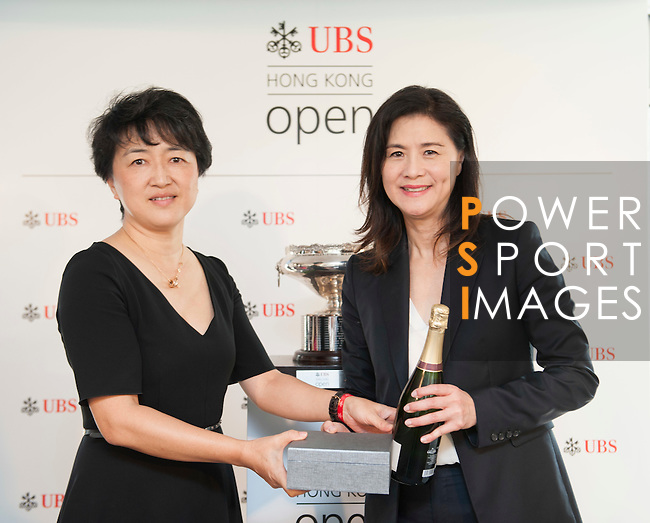Write a detailed description of this image, do not forget about the texts on it if they exist. Also, do not forget to mention the type / style of the image. No bullet points. The color photograph captures two women standing together in front of a promotional display reading 'Hong Kong Open UBS'. The backdrop also includes, in large font, 'POWER SPORT IMAGES'. The woman on the left, sporting black attire with short sleeves, secures the base of a gray presentation box. The woman on the right holds the lid of the box in one hand and a gleaming bottle of champagne in the other, dressed in a dark blazer over a white top. Both women are wearing professional clothing and offer warm smiles towards the camera. In the soft-focus background, a gleaming silver trophy can be glimpsed resting on a pedestal. The image does not overtly suggest a sporting or competitive event, but the presence of logos, the trophy, and the champagne hint at some form of congratulatory ceremony or celebration. 